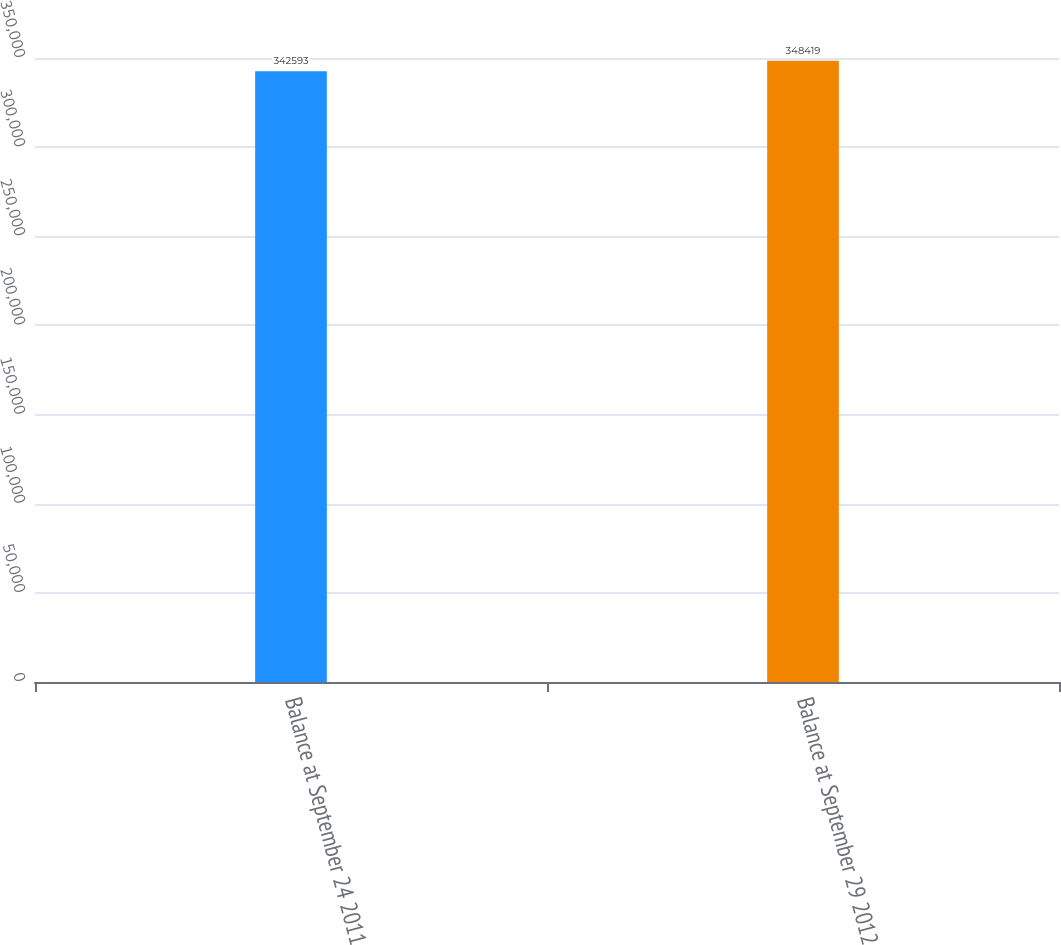Convert chart to OTSL. <chart><loc_0><loc_0><loc_500><loc_500><bar_chart><fcel>Balance at September 24 2011<fcel>Balance at September 29 2012<nl><fcel>342593<fcel>348419<nl></chart> 